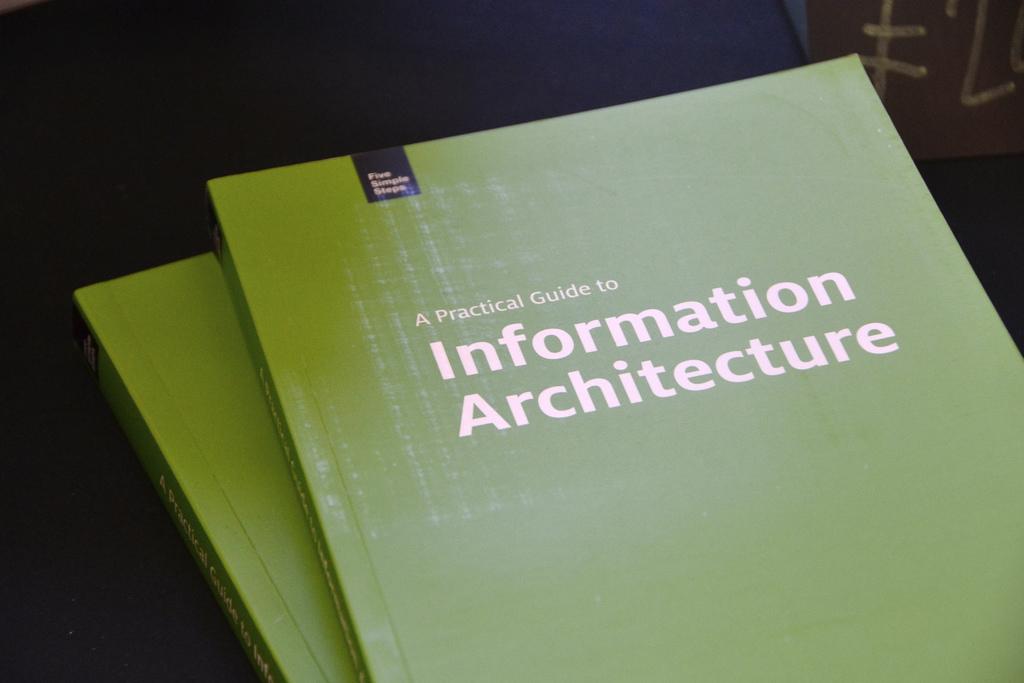What kind of guide is the book?
Make the answer very short. Information architecture. 